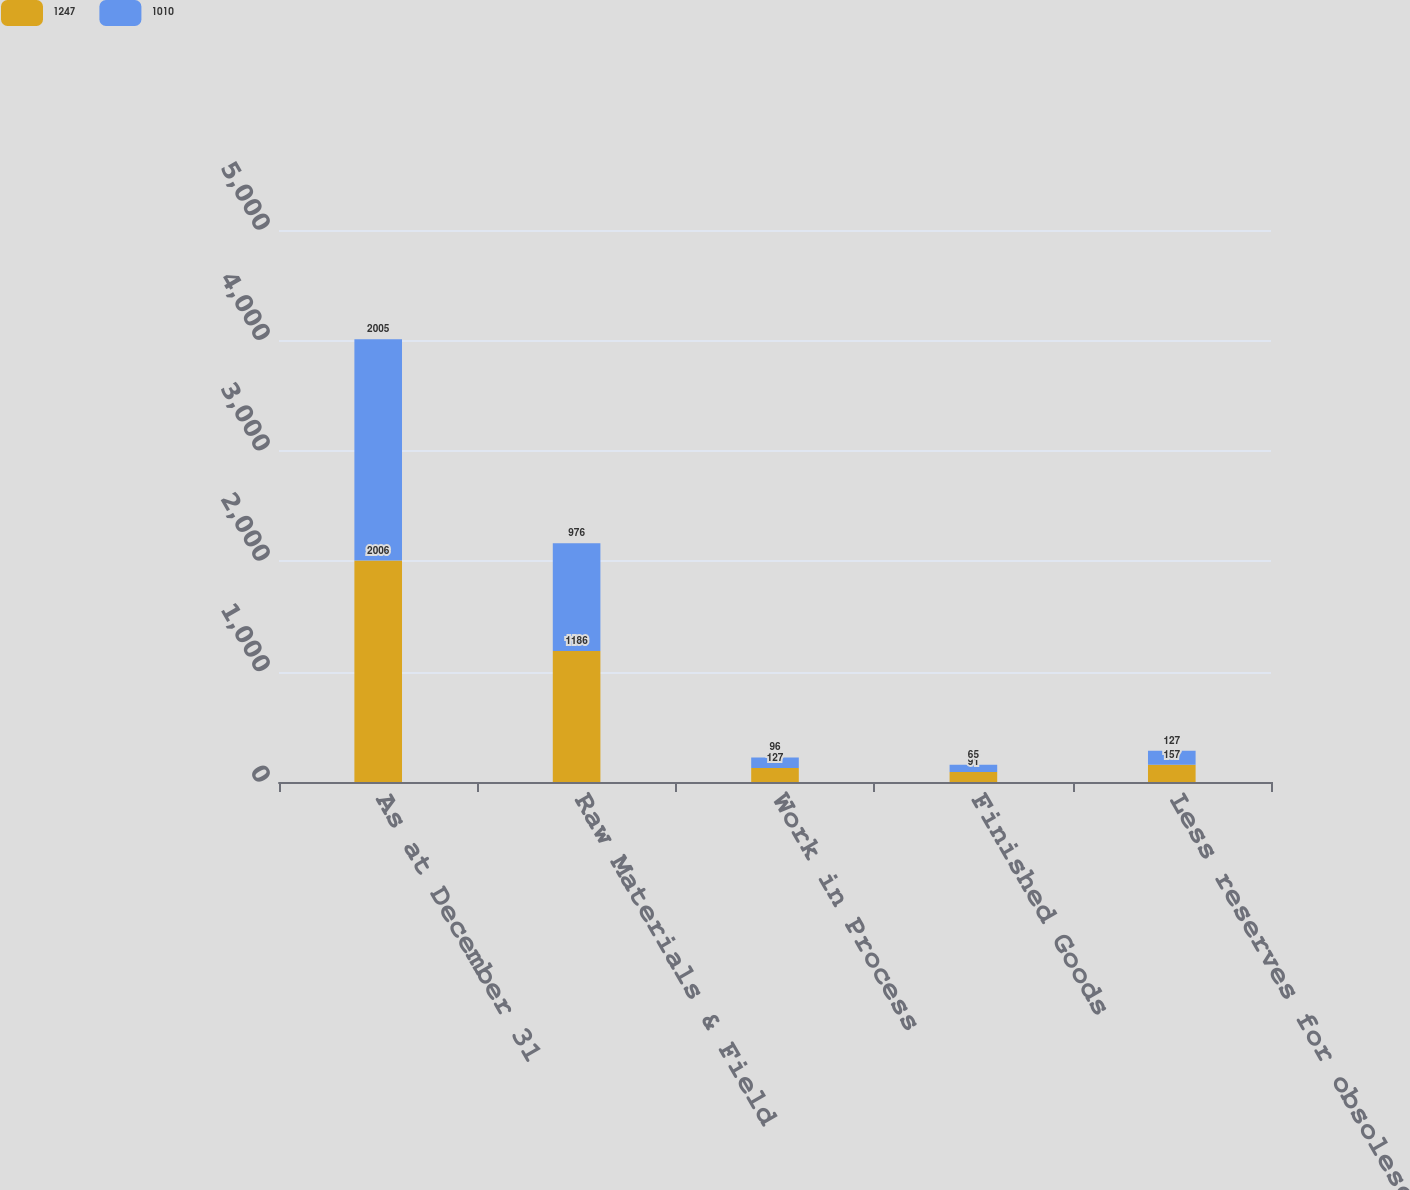Convert chart. <chart><loc_0><loc_0><loc_500><loc_500><stacked_bar_chart><ecel><fcel>As at December 31<fcel>Raw Materials & Field<fcel>Work in Process<fcel>Finished Goods<fcel>Less reserves for obsolescence<nl><fcel>1247<fcel>2006<fcel>1186<fcel>127<fcel>91<fcel>157<nl><fcel>1010<fcel>2005<fcel>976<fcel>96<fcel>65<fcel>127<nl></chart> 